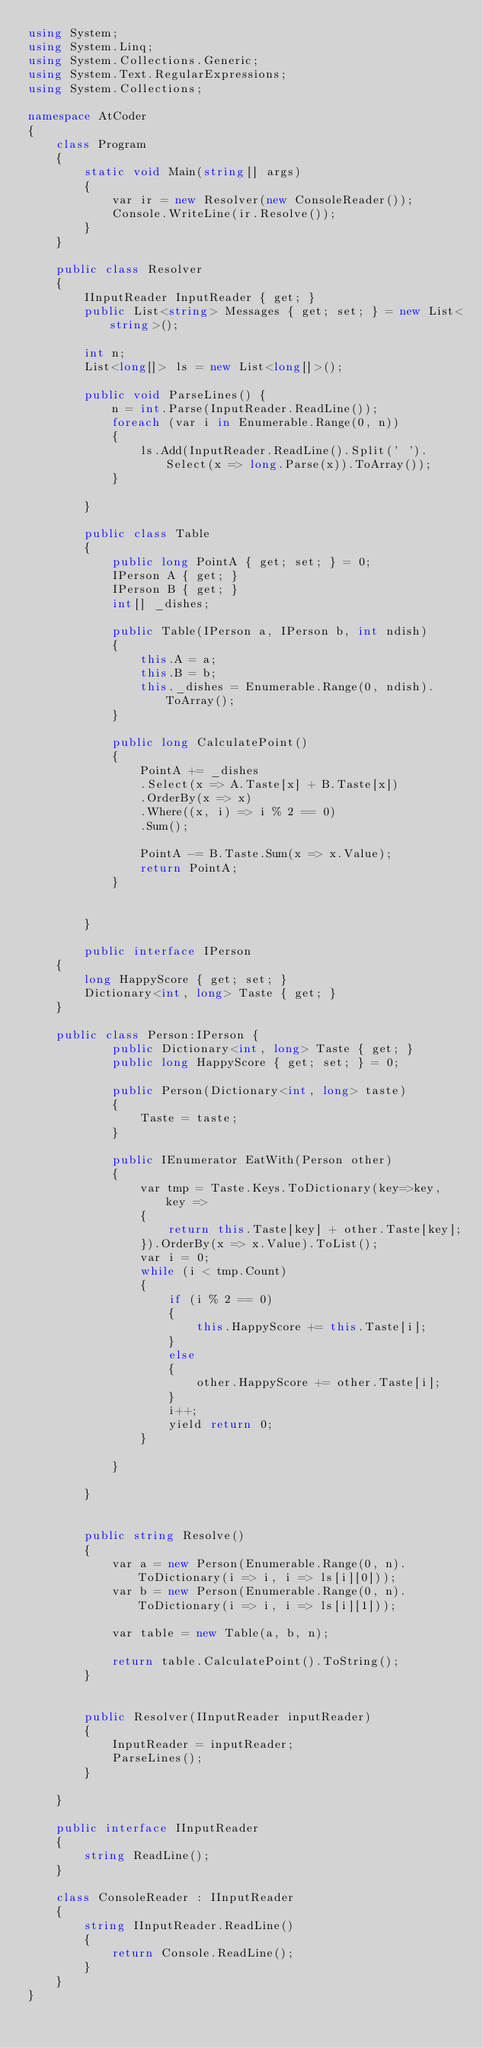Convert code to text. <code><loc_0><loc_0><loc_500><loc_500><_C#_>using System;
using System.Linq;
using System.Collections.Generic;
using System.Text.RegularExpressions;
using System.Collections;

namespace AtCoder
{
    class Program
    {
        static void Main(string[] args)
        {
            var ir = new Resolver(new ConsoleReader());
            Console.WriteLine(ir.Resolve());
        }
    }

    public class Resolver
    {
        IInputReader InputReader { get; }
        public List<string> Messages { get; set; } = new List<string>();

        int n;
        List<long[]> ls = new List<long[]>();

        public void ParseLines() {
            n = int.Parse(InputReader.ReadLine());
            foreach (var i in Enumerable.Range(0, n))
            {
                ls.Add(InputReader.ReadLine().Split(' ').Select(x => long.Parse(x)).ToArray());
            }

        }

        public class Table
        {
            public long PointA { get; set; } = 0;
            IPerson A { get; }
            IPerson B { get; }
            int[] _dishes;

            public Table(IPerson a, IPerson b, int ndish)
            {
                this.A = a;
                this.B = b;
                this._dishes = Enumerable.Range(0, ndish).ToArray();
            }

            public long CalculatePoint()
            {
                PointA += _dishes
                .Select(x => A.Taste[x] + B.Taste[x])
                .OrderBy(x => x)
                .Where((x, i) => i % 2 == 0)
                .Sum();

                PointA -= B.Taste.Sum(x => x.Value);
                return PointA;
            }


        }

        public interface IPerson
    {
        long HappyScore { get; set; }
        Dictionary<int, long> Taste { get; }
    }

    public class Person:IPerson {
            public Dictionary<int, long> Taste { get; }
            public long HappyScore { get; set; } = 0;

            public Person(Dictionary<int, long> taste)
            {
                Taste = taste;
            }

            public IEnumerator EatWith(Person other)
            {
                var tmp = Taste.Keys.ToDictionary(key=>key, key =>
                {
                    return this.Taste[key] + other.Taste[key];
                }).OrderBy(x => x.Value).ToList();
                var i = 0;
                while (i < tmp.Count)
                {
                    if (i % 2 == 0)
                    {
                        this.HappyScore += this.Taste[i];
                    }
                    else
                    {
                        other.HappyScore += other.Taste[i];
                    }
                    i++;
                    yield return 0;
                }

            }

        }


        public string Resolve()
        {
            var a = new Person(Enumerable.Range(0, n).ToDictionary(i => i, i => ls[i][0]));
            var b = new Person(Enumerable.Range(0, n).ToDictionary(i => i, i => ls[i][1]));

            var table = new Table(a, b, n);

            return table.CalculatePoint().ToString();
        }


        public Resolver(IInputReader inputReader)
        {
            InputReader = inputReader;
            ParseLines();
        }

    }

    public interface IInputReader
    {
        string ReadLine();
    }

    class ConsoleReader : IInputReader
    {
        string IInputReader.ReadLine()
        {
            return Console.ReadLine();
        }
    }
}

</code> 